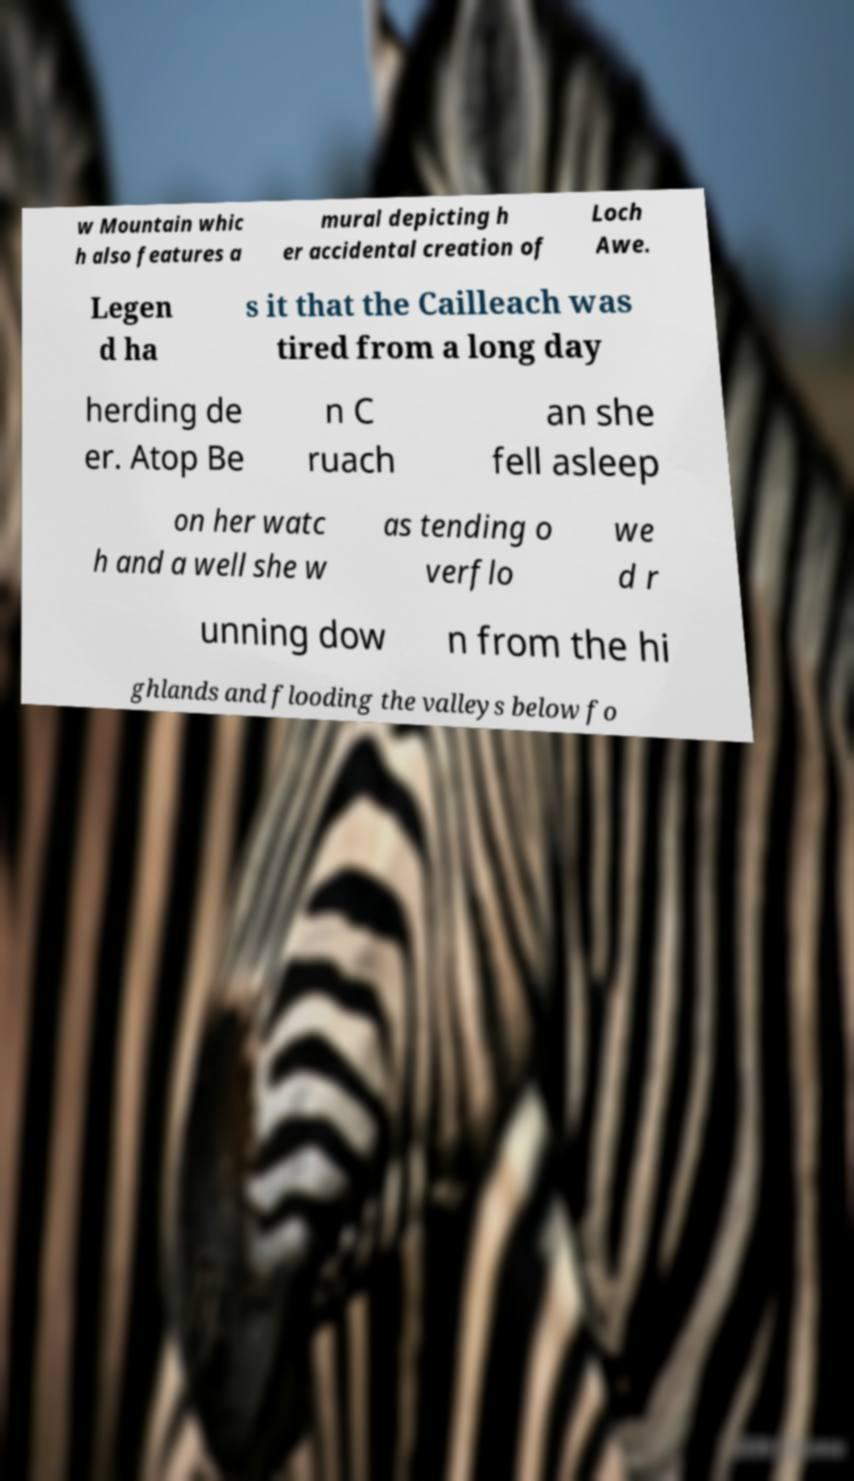Please identify and transcribe the text found in this image. w Mountain whic h also features a mural depicting h er accidental creation of Loch Awe. Legen d ha s it that the Cailleach was tired from a long day herding de er. Atop Be n C ruach an she fell asleep on her watc h and a well she w as tending o verflo we d r unning dow n from the hi ghlands and flooding the valleys below fo 